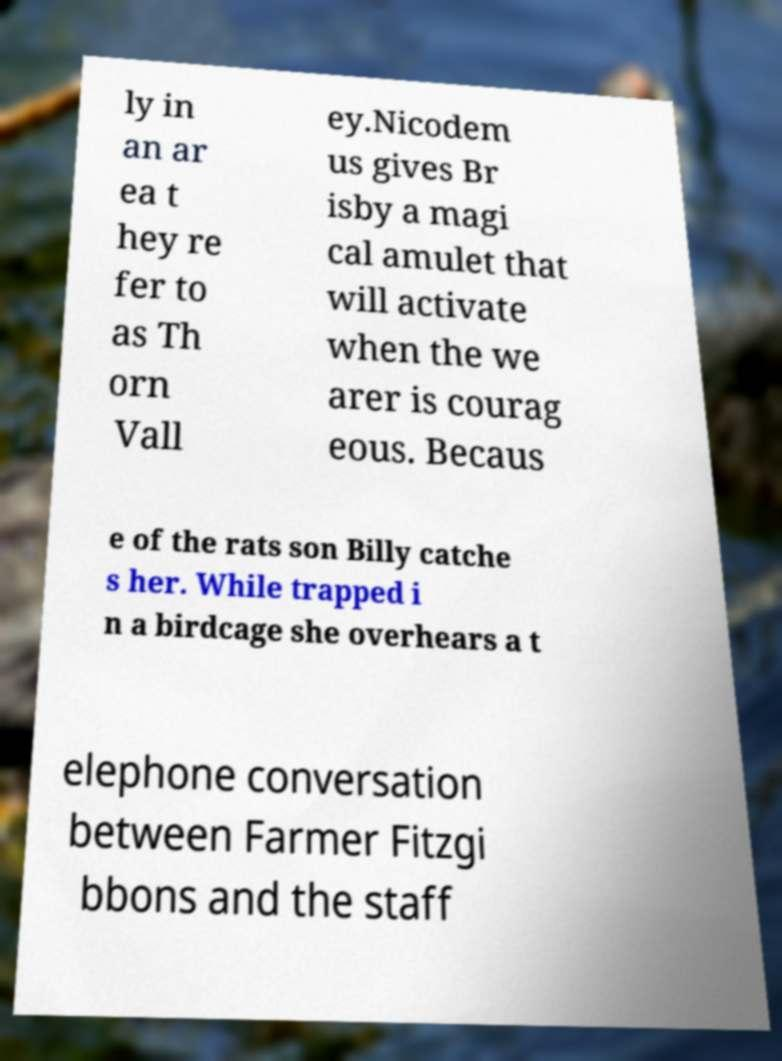Could you assist in decoding the text presented in this image and type it out clearly? ly in an ar ea t hey re fer to as Th orn Vall ey.Nicodem us gives Br isby a magi cal amulet that will activate when the we arer is courag eous. Becaus e of the rats son Billy catche s her. While trapped i n a birdcage she overhears a t elephone conversation between Farmer Fitzgi bbons and the staff 